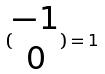<formula> <loc_0><loc_0><loc_500><loc_500>( \begin{matrix} - 1 \\ 0 \end{matrix} ) = 1</formula> 